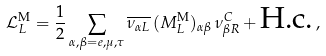<formula> <loc_0><loc_0><loc_500><loc_500>\mathcal { L } _ { L } ^ { \text {M} } = \frac { 1 } { 2 } \sum _ { \alpha , \beta = e , \mu , \tau } \overline { \nu _ { { \alpha } L } } \, ( M _ { L } ^ { \text {M} } ) _ { \alpha \beta } \, \nu ^ { C } _ { { \beta } R } + \text {H.c.} \, ,</formula> 